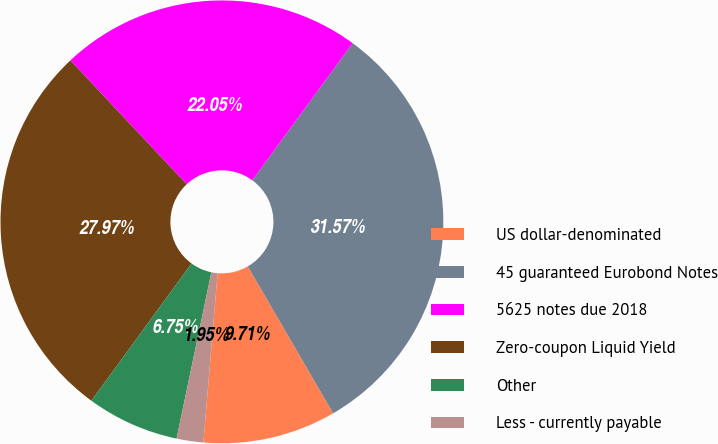<chart> <loc_0><loc_0><loc_500><loc_500><pie_chart><fcel>US dollar-denominated<fcel>45 guaranteed Eurobond Notes<fcel>5625 notes due 2018<fcel>Zero-coupon Liquid Yield<fcel>Other<fcel>Less - currently payable<nl><fcel>9.71%<fcel>31.57%<fcel>22.05%<fcel>27.97%<fcel>6.75%<fcel>1.95%<nl></chart> 